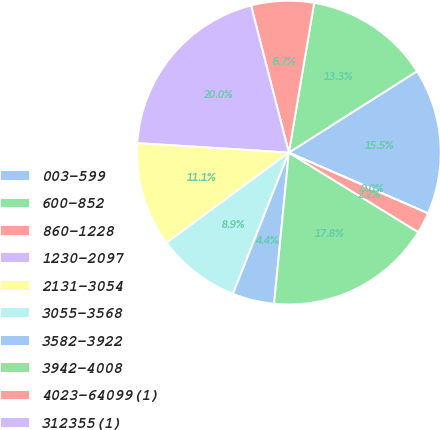Convert chart. <chart><loc_0><loc_0><loc_500><loc_500><pie_chart><fcel>003-599<fcel>600-852<fcel>860-1228<fcel>1230-2097<fcel>2131-3054<fcel>3055-3568<fcel>3582-3922<fcel>3942-4008<fcel>4023-64099(1)<fcel>312355(1)<nl><fcel>15.55%<fcel>13.33%<fcel>6.67%<fcel>20.0%<fcel>11.11%<fcel>8.89%<fcel>4.45%<fcel>17.78%<fcel>2.22%<fcel>0.0%<nl></chart> 